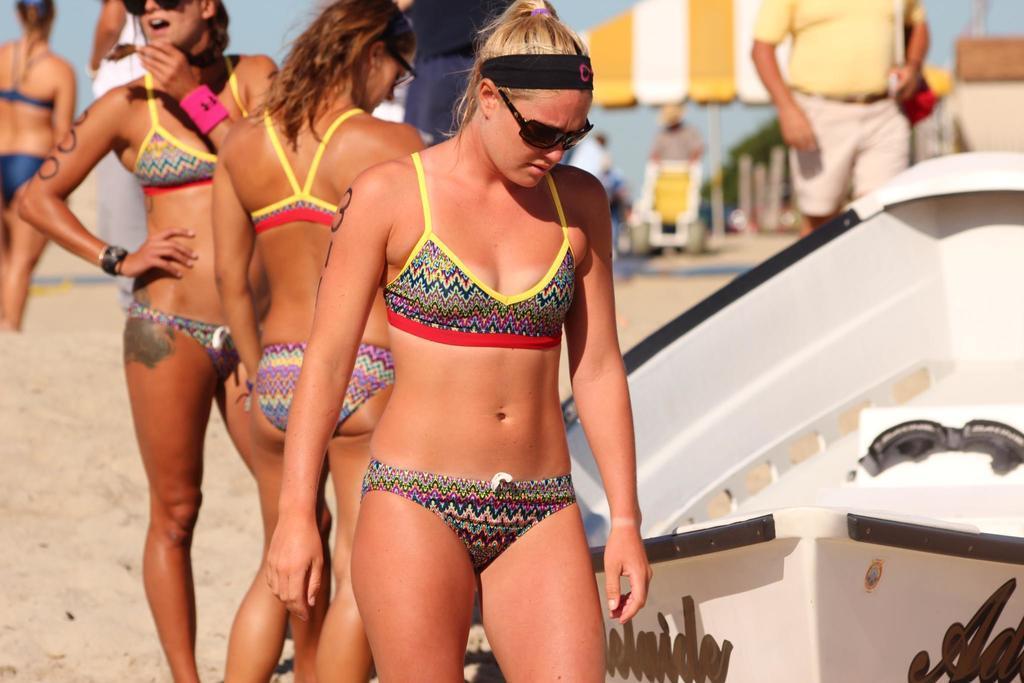Describe this image in one or two sentences. In this picture I can see few people standing, few are wearing sunglasses and looks like a tent in the background. I can see a human wearing a bag and a boat on the ground and I can see a blue sky. 